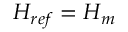Convert formula to latex. <formula><loc_0><loc_0><loc_500><loc_500>H _ { r e f } = H _ { m }</formula> 